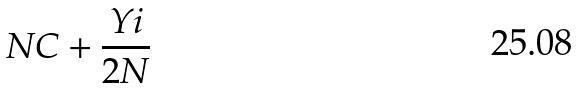Convert formula to latex. <formula><loc_0><loc_0><loc_500><loc_500>N C + \frac { Y i } { 2 N }</formula> 